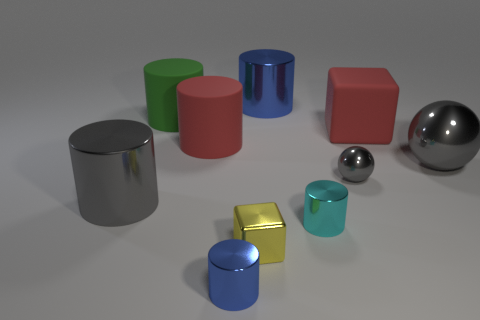The matte object that is to the right of the cube in front of the big red cylinder is what shape?
Offer a terse response. Cube. There is a big gray object that is behind the large gray object that is left of the small blue cylinder; what number of big blue cylinders are on the right side of it?
Offer a very short reply. 0. Are there fewer tiny shiny things that are in front of the tiny metallic sphere than tiny green matte cubes?
Your answer should be compact. No. The large gray thing that is left of the large shiny sphere has what shape?
Your answer should be compact. Cylinder. What shape is the blue thing that is left of the big metallic object behind the cube that is behind the tiny cyan cylinder?
Your answer should be very brief. Cylinder. What number of things are either rubber balls or gray metal things?
Your answer should be very brief. 3. There is a gray metallic object that is left of the small cyan metallic cylinder; is it the same shape as the small metal object behind the cyan shiny cylinder?
Ensure brevity in your answer.  No. What number of cylinders are both on the right side of the yellow metal cube and in front of the green cylinder?
Your response must be concise. 1. What number of other objects are there of the same size as the red matte cylinder?
Your response must be concise. 5. What is the material of the thing that is both behind the big red block and on the left side of the tiny block?
Ensure brevity in your answer.  Rubber. 